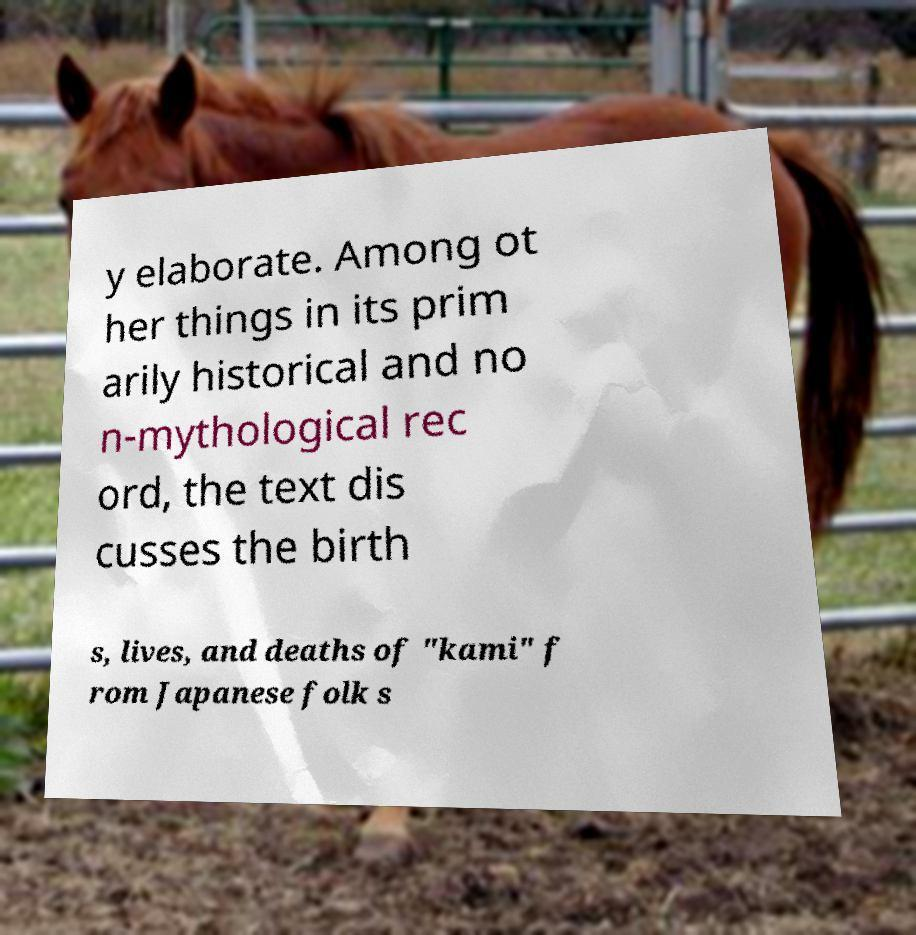Can you accurately transcribe the text from the provided image for me? y elaborate. Among ot her things in its prim arily historical and no n-mythological rec ord, the text dis cusses the birth s, lives, and deaths of "kami" f rom Japanese folk s 